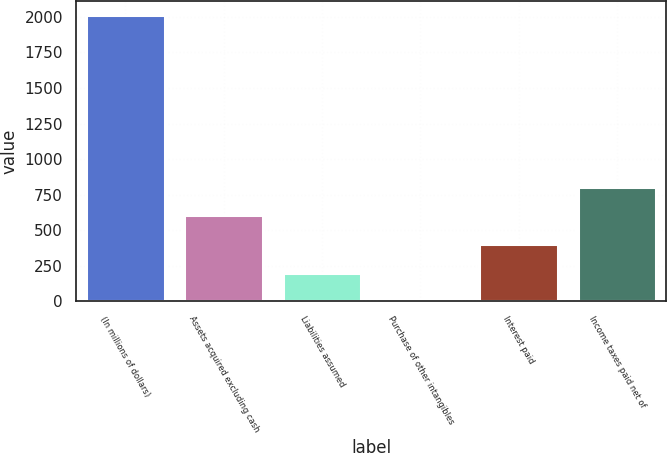Convert chart. <chart><loc_0><loc_0><loc_500><loc_500><bar_chart><fcel>(In millions of dollars)<fcel>Assets acquired excluding cash<fcel>Liabilities assumed<fcel>Purchase of other intangibles<fcel>Interest paid<fcel>Income taxes paid net of<nl><fcel>2013<fcel>605.3<fcel>203.1<fcel>2<fcel>404.2<fcel>806.4<nl></chart> 